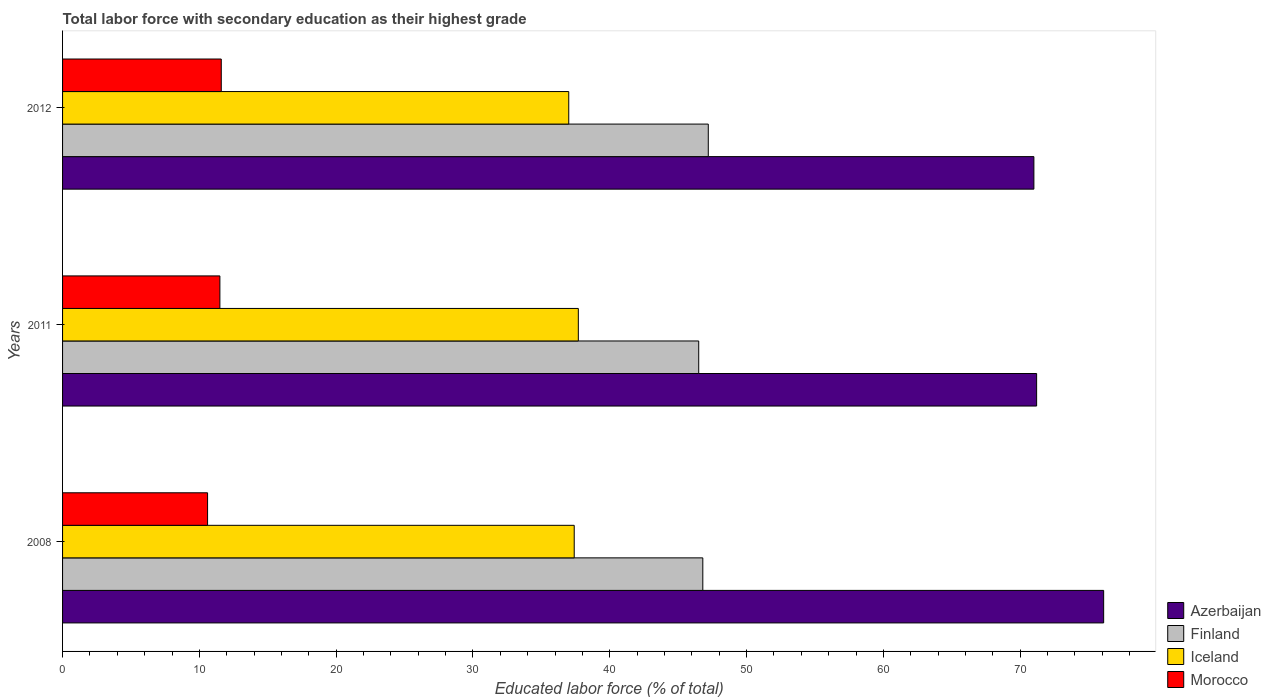How many groups of bars are there?
Provide a short and direct response. 3. How many bars are there on the 1st tick from the top?
Keep it short and to the point. 4. What is the label of the 1st group of bars from the top?
Ensure brevity in your answer.  2012. What is the percentage of total labor force with primary education in Azerbaijan in 2011?
Your answer should be very brief. 71.2. Across all years, what is the maximum percentage of total labor force with primary education in Iceland?
Offer a terse response. 37.7. Across all years, what is the minimum percentage of total labor force with primary education in Azerbaijan?
Your response must be concise. 71. In which year was the percentage of total labor force with primary education in Azerbaijan maximum?
Your response must be concise. 2008. What is the total percentage of total labor force with primary education in Finland in the graph?
Ensure brevity in your answer.  140.5. What is the difference between the percentage of total labor force with primary education in Azerbaijan in 2008 and that in 2012?
Give a very brief answer. 5.1. What is the difference between the percentage of total labor force with primary education in Azerbaijan in 2011 and the percentage of total labor force with primary education in Morocco in 2008?
Keep it short and to the point. 60.6. What is the average percentage of total labor force with primary education in Morocco per year?
Your response must be concise. 11.23. In the year 2012, what is the difference between the percentage of total labor force with primary education in Finland and percentage of total labor force with primary education in Azerbaijan?
Keep it short and to the point. -23.8. What is the ratio of the percentage of total labor force with primary education in Iceland in 2011 to that in 2012?
Your answer should be very brief. 1.02. Is the percentage of total labor force with primary education in Azerbaijan in 2008 less than that in 2012?
Your response must be concise. No. What is the difference between the highest and the second highest percentage of total labor force with primary education in Iceland?
Give a very brief answer. 0.3. What is the difference between the highest and the lowest percentage of total labor force with primary education in Iceland?
Make the answer very short. 0.7. Is the sum of the percentage of total labor force with primary education in Iceland in 2008 and 2011 greater than the maximum percentage of total labor force with primary education in Azerbaijan across all years?
Give a very brief answer. No. What does the 2nd bar from the top in 2012 represents?
Provide a short and direct response. Iceland. What does the 1st bar from the bottom in 2011 represents?
Your answer should be compact. Azerbaijan. How many years are there in the graph?
Your answer should be compact. 3. What is the difference between two consecutive major ticks on the X-axis?
Keep it short and to the point. 10. Are the values on the major ticks of X-axis written in scientific E-notation?
Make the answer very short. No. Does the graph contain any zero values?
Keep it short and to the point. No. What is the title of the graph?
Ensure brevity in your answer.  Total labor force with secondary education as their highest grade. Does "Costa Rica" appear as one of the legend labels in the graph?
Provide a succinct answer. No. What is the label or title of the X-axis?
Ensure brevity in your answer.  Educated labor force (% of total). What is the Educated labor force (% of total) in Azerbaijan in 2008?
Keep it short and to the point. 76.1. What is the Educated labor force (% of total) in Finland in 2008?
Offer a terse response. 46.8. What is the Educated labor force (% of total) in Iceland in 2008?
Your response must be concise. 37.4. What is the Educated labor force (% of total) in Morocco in 2008?
Provide a succinct answer. 10.6. What is the Educated labor force (% of total) of Azerbaijan in 2011?
Offer a terse response. 71.2. What is the Educated labor force (% of total) of Finland in 2011?
Offer a very short reply. 46.5. What is the Educated labor force (% of total) of Iceland in 2011?
Your answer should be compact. 37.7. What is the Educated labor force (% of total) of Finland in 2012?
Your answer should be compact. 47.2. What is the Educated labor force (% of total) in Iceland in 2012?
Provide a short and direct response. 37. What is the Educated labor force (% of total) of Morocco in 2012?
Offer a terse response. 11.6. Across all years, what is the maximum Educated labor force (% of total) of Azerbaijan?
Offer a very short reply. 76.1. Across all years, what is the maximum Educated labor force (% of total) of Finland?
Offer a terse response. 47.2. Across all years, what is the maximum Educated labor force (% of total) in Iceland?
Offer a very short reply. 37.7. Across all years, what is the maximum Educated labor force (% of total) of Morocco?
Keep it short and to the point. 11.6. Across all years, what is the minimum Educated labor force (% of total) in Finland?
Ensure brevity in your answer.  46.5. Across all years, what is the minimum Educated labor force (% of total) of Iceland?
Give a very brief answer. 37. Across all years, what is the minimum Educated labor force (% of total) in Morocco?
Provide a succinct answer. 10.6. What is the total Educated labor force (% of total) of Azerbaijan in the graph?
Your answer should be very brief. 218.3. What is the total Educated labor force (% of total) in Finland in the graph?
Your answer should be compact. 140.5. What is the total Educated labor force (% of total) of Iceland in the graph?
Your response must be concise. 112.1. What is the total Educated labor force (% of total) in Morocco in the graph?
Provide a short and direct response. 33.7. What is the difference between the Educated labor force (% of total) of Azerbaijan in 2008 and that in 2011?
Make the answer very short. 4.9. What is the difference between the Educated labor force (% of total) in Iceland in 2008 and that in 2011?
Provide a succinct answer. -0.3. What is the difference between the Educated labor force (% of total) in Azerbaijan in 2008 and that in 2012?
Keep it short and to the point. 5.1. What is the difference between the Educated labor force (% of total) of Finland in 2008 and that in 2012?
Your response must be concise. -0.4. What is the difference between the Educated labor force (% of total) in Finland in 2011 and that in 2012?
Offer a terse response. -0.7. What is the difference between the Educated labor force (% of total) in Azerbaijan in 2008 and the Educated labor force (% of total) in Finland in 2011?
Ensure brevity in your answer.  29.6. What is the difference between the Educated labor force (% of total) in Azerbaijan in 2008 and the Educated labor force (% of total) in Iceland in 2011?
Provide a short and direct response. 38.4. What is the difference between the Educated labor force (% of total) in Azerbaijan in 2008 and the Educated labor force (% of total) in Morocco in 2011?
Provide a short and direct response. 64.6. What is the difference between the Educated labor force (% of total) in Finland in 2008 and the Educated labor force (% of total) in Iceland in 2011?
Your response must be concise. 9.1. What is the difference between the Educated labor force (% of total) in Finland in 2008 and the Educated labor force (% of total) in Morocco in 2011?
Make the answer very short. 35.3. What is the difference between the Educated labor force (% of total) of Iceland in 2008 and the Educated labor force (% of total) of Morocco in 2011?
Ensure brevity in your answer.  25.9. What is the difference between the Educated labor force (% of total) of Azerbaijan in 2008 and the Educated labor force (% of total) of Finland in 2012?
Provide a short and direct response. 28.9. What is the difference between the Educated labor force (% of total) in Azerbaijan in 2008 and the Educated labor force (% of total) in Iceland in 2012?
Provide a short and direct response. 39.1. What is the difference between the Educated labor force (% of total) of Azerbaijan in 2008 and the Educated labor force (% of total) of Morocco in 2012?
Your answer should be compact. 64.5. What is the difference between the Educated labor force (% of total) of Finland in 2008 and the Educated labor force (% of total) of Morocco in 2012?
Your response must be concise. 35.2. What is the difference between the Educated labor force (% of total) in Iceland in 2008 and the Educated labor force (% of total) in Morocco in 2012?
Make the answer very short. 25.8. What is the difference between the Educated labor force (% of total) of Azerbaijan in 2011 and the Educated labor force (% of total) of Iceland in 2012?
Provide a short and direct response. 34.2. What is the difference between the Educated labor force (% of total) in Azerbaijan in 2011 and the Educated labor force (% of total) in Morocco in 2012?
Offer a very short reply. 59.6. What is the difference between the Educated labor force (% of total) of Finland in 2011 and the Educated labor force (% of total) of Morocco in 2012?
Your response must be concise. 34.9. What is the difference between the Educated labor force (% of total) in Iceland in 2011 and the Educated labor force (% of total) in Morocco in 2012?
Ensure brevity in your answer.  26.1. What is the average Educated labor force (% of total) of Azerbaijan per year?
Keep it short and to the point. 72.77. What is the average Educated labor force (% of total) in Finland per year?
Keep it short and to the point. 46.83. What is the average Educated labor force (% of total) of Iceland per year?
Provide a short and direct response. 37.37. What is the average Educated labor force (% of total) of Morocco per year?
Give a very brief answer. 11.23. In the year 2008, what is the difference between the Educated labor force (% of total) of Azerbaijan and Educated labor force (% of total) of Finland?
Provide a short and direct response. 29.3. In the year 2008, what is the difference between the Educated labor force (% of total) in Azerbaijan and Educated labor force (% of total) in Iceland?
Your answer should be very brief. 38.7. In the year 2008, what is the difference between the Educated labor force (% of total) of Azerbaijan and Educated labor force (% of total) of Morocco?
Make the answer very short. 65.5. In the year 2008, what is the difference between the Educated labor force (% of total) in Finland and Educated labor force (% of total) in Morocco?
Ensure brevity in your answer.  36.2. In the year 2008, what is the difference between the Educated labor force (% of total) of Iceland and Educated labor force (% of total) of Morocco?
Your answer should be very brief. 26.8. In the year 2011, what is the difference between the Educated labor force (% of total) of Azerbaijan and Educated labor force (% of total) of Finland?
Your answer should be very brief. 24.7. In the year 2011, what is the difference between the Educated labor force (% of total) of Azerbaijan and Educated labor force (% of total) of Iceland?
Offer a very short reply. 33.5. In the year 2011, what is the difference between the Educated labor force (% of total) of Azerbaijan and Educated labor force (% of total) of Morocco?
Your answer should be compact. 59.7. In the year 2011, what is the difference between the Educated labor force (% of total) in Finland and Educated labor force (% of total) in Iceland?
Ensure brevity in your answer.  8.8. In the year 2011, what is the difference between the Educated labor force (% of total) of Finland and Educated labor force (% of total) of Morocco?
Your answer should be compact. 35. In the year 2011, what is the difference between the Educated labor force (% of total) of Iceland and Educated labor force (% of total) of Morocco?
Make the answer very short. 26.2. In the year 2012, what is the difference between the Educated labor force (% of total) in Azerbaijan and Educated labor force (% of total) in Finland?
Your answer should be compact. 23.8. In the year 2012, what is the difference between the Educated labor force (% of total) in Azerbaijan and Educated labor force (% of total) in Morocco?
Ensure brevity in your answer.  59.4. In the year 2012, what is the difference between the Educated labor force (% of total) in Finland and Educated labor force (% of total) in Iceland?
Offer a very short reply. 10.2. In the year 2012, what is the difference between the Educated labor force (% of total) of Finland and Educated labor force (% of total) of Morocco?
Ensure brevity in your answer.  35.6. In the year 2012, what is the difference between the Educated labor force (% of total) of Iceland and Educated labor force (% of total) of Morocco?
Give a very brief answer. 25.4. What is the ratio of the Educated labor force (% of total) in Azerbaijan in 2008 to that in 2011?
Give a very brief answer. 1.07. What is the ratio of the Educated labor force (% of total) of Morocco in 2008 to that in 2011?
Make the answer very short. 0.92. What is the ratio of the Educated labor force (% of total) in Azerbaijan in 2008 to that in 2012?
Your response must be concise. 1.07. What is the ratio of the Educated labor force (% of total) of Iceland in 2008 to that in 2012?
Offer a very short reply. 1.01. What is the ratio of the Educated labor force (% of total) in Morocco in 2008 to that in 2012?
Provide a succinct answer. 0.91. What is the ratio of the Educated labor force (% of total) of Azerbaijan in 2011 to that in 2012?
Your answer should be compact. 1. What is the ratio of the Educated labor force (% of total) in Finland in 2011 to that in 2012?
Provide a short and direct response. 0.99. What is the ratio of the Educated labor force (% of total) of Iceland in 2011 to that in 2012?
Provide a short and direct response. 1.02. What is the ratio of the Educated labor force (% of total) in Morocco in 2011 to that in 2012?
Your response must be concise. 0.99. What is the difference between the highest and the second highest Educated labor force (% of total) of Iceland?
Give a very brief answer. 0.3. What is the difference between the highest and the second highest Educated labor force (% of total) in Morocco?
Your response must be concise. 0.1. What is the difference between the highest and the lowest Educated labor force (% of total) of Finland?
Keep it short and to the point. 0.7. What is the difference between the highest and the lowest Educated labor force (% of total) in Iceland?
Provide a succinct answer. 0.7. What is the difference between the highest and the lowest Educated labor force (% of total) of Morocco?
Give a very brief answer. 1. 